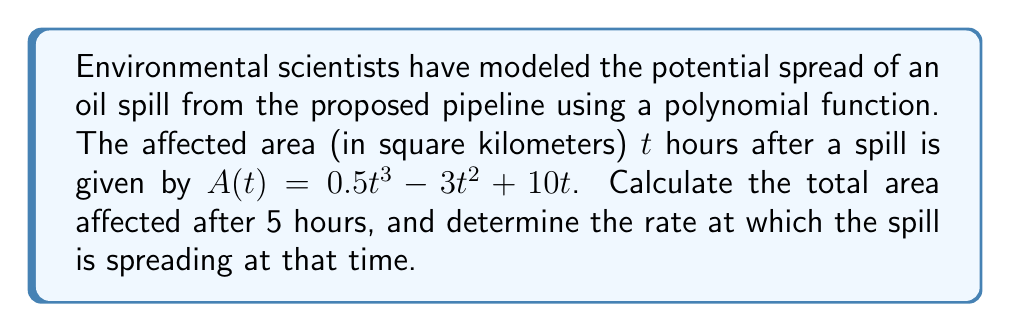Provide a solution to this math problem. To solve this problem, we'll follow these steps:

1. Calculate the area affected after 5 hours:
   Substitute $t = 5$ into the given function $A(t) = 0.5t^3 - 3t^2 + 10t$
   
   $$A(5) = 0.5(5^3) - 3(5^2) + 10(5)$$
   $$= 0.5(125) - 3(25) + 50$$
   $$= 62.5 - 75 + 50$$
   $$= 37.5 \text{ km}^2$$

2. To find the rate at which the spill is spreading at 5 hours, we need to calculate the derivative of $A(t)$ and evaluate it at $t = 5$:
   
   $$A'(t) = \frac{d}{dt}(0.5t^3 - 3t^2 + 10t)$$
   $$= 1.5t^2 - 6t + 10$$

3. Now, evaluate $A'(5)$:
   
   $$A'(5) = 1.5(5^2) - 6(5) + 10$$
   $$= 1.5(25) - 30 + 10$$
   $$= 37.5 - 30 + 10$$
   $$= 17.5 \text{ km}^2/\text{hour}$$
Answer: 37.5 km², 17.5 km²/hour 